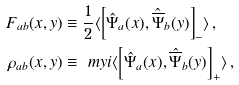<formula> <loc_0><loc_0><loc_500><loc_500>F _ { a b } ( x , y ) & \equiv \frac { 1 } { 2 } \langle \left [ \hat { \Psi } _ { a } ( x ) , \hat { \overline { \Psi } } _ { b } ( y ) \right ] _ { - } \rangle \, , \\ \rho _ { a b } ( x , y ) & \equiv \ m y i \langle \left [ \hat { \Psi } _ { a } ( x ) , \hat { \overline { \Psi } } _ { b } ( y ) \right ] _ { + } \rangle \, ,</formula> 